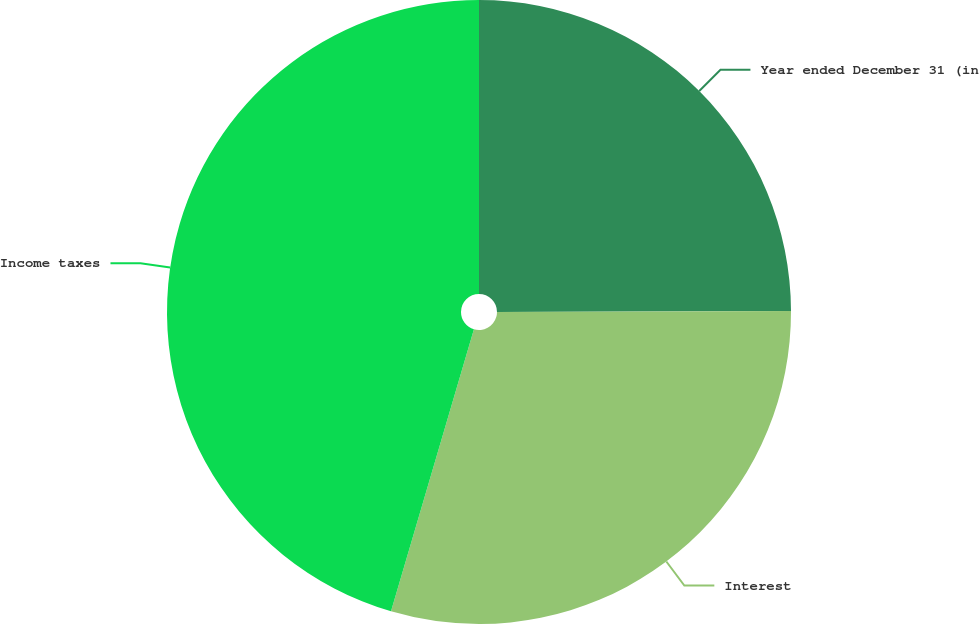<chart> <loc_0><loc_0><loc_500><loc_500><pie_chart><fcel>Year ended December 31 (in<fcel>Interest<fcel>Income taxes<nl><fcel>24.95%<fcel>29.6%<fcel>45.45%<nl></chart> 